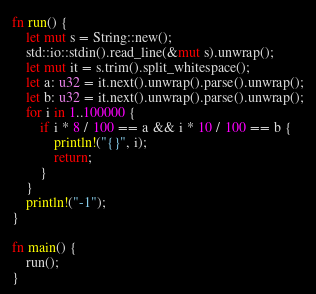<code> <loc_0><loc_0><loc_500><loc_500><_Rust_>fn run() {
    let mut s = String::new();
    std::io::stdin().read_line(&mut s).unwrap();
    let mut it = s.trim().split_whitespace();
    let a: u32 = it.next().unwrap().parse().unwrap();
    let b: u32 = it.next().unwrap().parse().unwrap();
    for i in 1..100000 {
        if i * 8 / 100 == a && i * 10 / 100 == b {
            println!("{}", i);
            return;
        }
    }
    println!("-1");
}

fn main() {
    run();
}</code> 